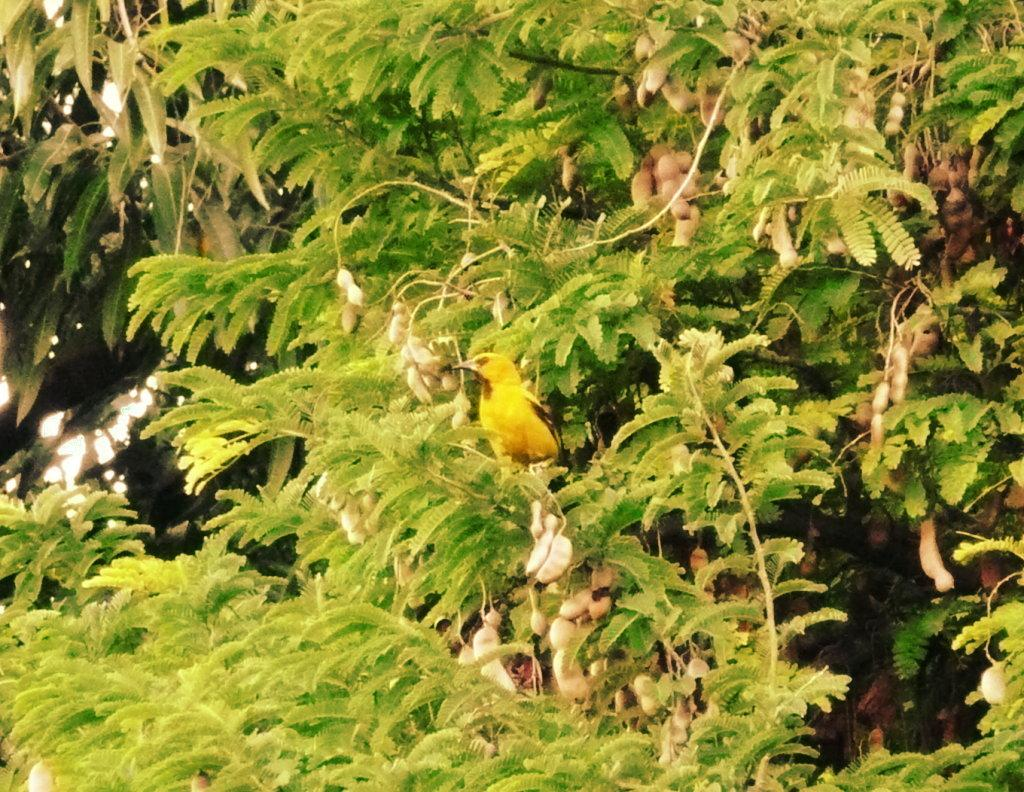What type of vegetation can be seen in the image? There are trees in the image. Is there any wildlife present in the image? Yes, there is a bird on one of the trees. What colors can be observed on the bird? The bird has yellow and black coloration. What type of toothpaste is the bird using to clean its beak in the image? There is no toothpaste present in the image, and birds do not use toothpaste to clean their beaks. 